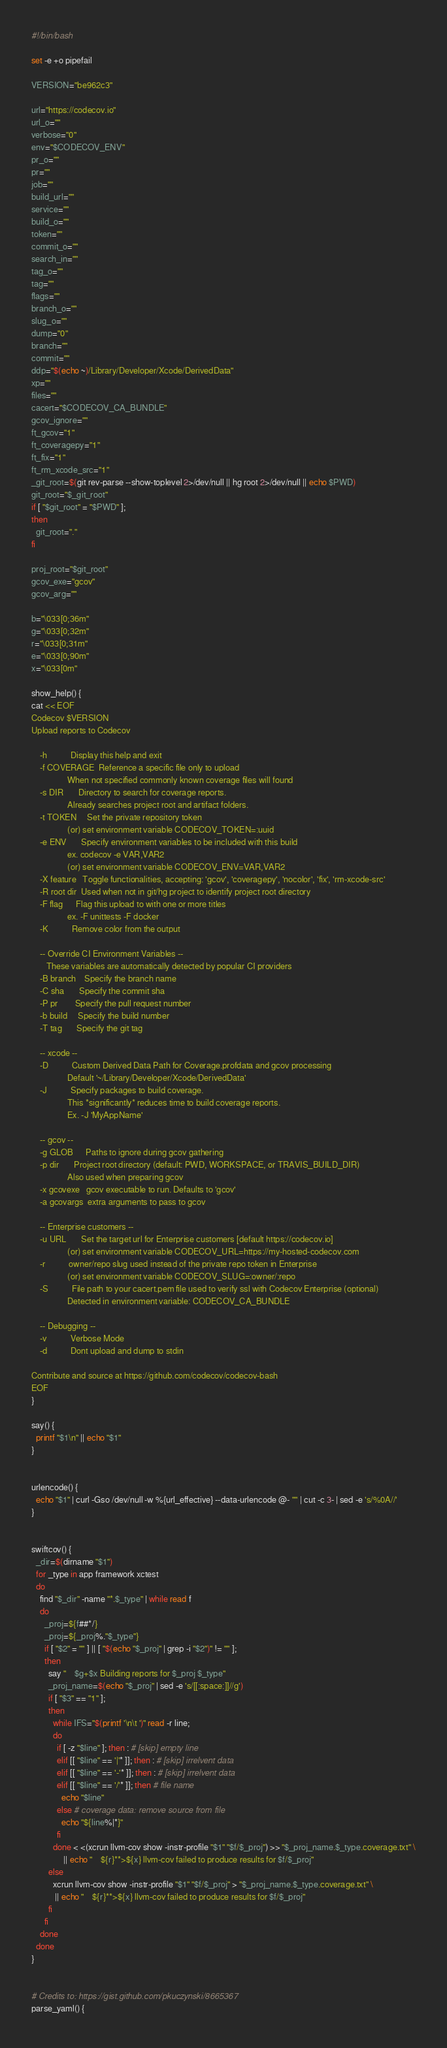<code> <loc_0><loc_0><loc_500><loc_500><_Bash_>
#!/bin/bash

set -e +o pipefail

VERSION="be962c3"

url="https://codecov.io"
url_o=""
verbose="0"
env="$CODECOV_ENV"
pr_o=""
pr=""
job=""
build_url=""
service=""
build_o=""
token=""
commit_o=""
search_in=""
tag_o=""
tag=""
flags=""
branch_o=""
slug_o=""
dump="0"
branch=""
commit=""
ddp="$(echo ~)/Library/Developer/Xcode/DerivedData"
xp=""
files=""
cacert="$CODECOV_CA_BUNDLE"
gcov_ignore=""
ft_gcov="1"
ft_coveragepy="1"
ft_fix="1"
ft_rm_xcode_src="1"
_git_root=$(git rev-parse --show-toplevel 2>/dev/null || hg root 2>/dev/null || echo $PWD)
git_root="$_git_root"
if [ "$git_root" = "$PWD" ];
then
  git_root="."
fi

proj_root="$git_root"
gcov_exe="gcov"
gcov_arg=""

b="\033[0;36m"
g="\033[0;32m"
r="\033[0;31m"
e="\033[0;90m"
x="\033[0m"

show_help() {
cat << EOF
Codecov $VERSION
Upload reports to Codecov

    -h           Display this help and exit
    -f COVERAGE  Reference a specific file only to upload
                 When not specified commonly known coverage files will found
    -s DIR       Directory to search for coverage reports.
                 Already searches project root and artifact folders.
    -t TOKEN     Set the private repository token
                 (or) set environment variable CODECOV_TOKEN=:uuid
    -e ENV       Specify environment variables to be included with this build
                 ex. codecov -e VAR,VAR2
                 (or) set environment variable CODECOV_ENV=VAR,VAR2
    -X feature   Toggle functionalities, accepting: 'gcov', 'coveragepy', 'nocolor', 'fix', 'rm-xcode-src'
    -R root dir  Used when not in git/hg project to identify project root directory
    -F flag      Flag this upload to with one or more titles
                 ex. -F unittests -F docker
    -K           Remove color from the output

    -- Override CI Environment Variables --
       These variables are automatically detected by popular CI providers
    -B branch    Specify the branch name
    -C sha       Specify the commit sha
    -P pr        Specify the pull request number
    -b build     Specify the build number
    -T tag       Specify the git tag

    -- xcode --
    -D           Custom Derived Data Path for Coverage.profdata and gcov processing
                 Default '~/Library/Developer/Xcode/DerivedData'
    -J           Specify packages to build coverage.
                 This *significantly* reduces time to build coverage reports.
                 Ex. -J 'MyAppName'

    -- gcov --
    -g GLOB      Paths to ignore during gcov gathering
    -p dir       Project root directory (default: PWD, WORKSPACE, or TRAVIS_BUILD_DIR)
                 Also used when preparing gcov
    -x gcovexe   gcov executable to run. Defaults to 'gcov'
    -a gcovargs  extra arguments to pass to gcov

    -- Enterprise customers --
    -u URL       Set the target url for Enterprise customers [default https://codecov.io]
                 (or) set environment variable CODECOV_URL=https://my-hosted-codecov.com
    -r           owner/repo slug used instead of the private repo token in Enterprise
                 (or) set environment variable CODECOV_SLUG=:owner/:repo
    -S           File path to your cacert.pem file used to verify ssl with Codecov Enterprise (optional)
                 Detected in environment variable: CODECOV_CA_BUNDLE

    -- Debugging --
    -v           Verbose Mode
    -d           Dont upload and dump to stdin

Contribute and source at https://github.com/codecov/codecov-bash
EOF
}

say() {
  printf "$1\n" || echo "$1"
}


urlencode() {
  echo "$1" | curl -Gso /dev/null -w %{url_effective} --data-urlencode @- "" | cut -c 3- | sed -e 's/%0A//'
}


swiftcov() {
  _dir=$(dirname "$1")
  for _type in app framework xctest
  do
    find "$_dir" -name "*.$_type" | while read f
    do
      _proj=${f##*/}
      _proj=${_proj%."$_type"}
      if [ "$2" = "" ] || [ "$(echo "$_proj" | grep -i "$2")" != "" ];
      then
        say "    $g+$x Building reports for $_proj $_type"
        _proj_name=$(echo "$_proj" | sed -e 's/[[:space:]]//g')
        if [ "$3" == "1" ];
        then
          while IFS="$(printf '\n\t ')" read -r line;
          do
            if [ -z "$line" ]; then : # [skip] empty line
            elif [[ "$line" == '|'* ]]; then : # [skip] irrelvent data
            elif [[ "$line" == '-'* ]]; then : # [skip] irrelvent data
            elif [[ "$line" == '/'* ]]; then # file name
              echo "$line"
            else # coverage data: remove source from file
              echo "${line%|*}"
            fi
          done < <(xcrun llvm-cov show -instr-profile "$1" "$f/$_proj") >> "$_proj_name.$_type.coverage.txt" \
               || echo "    ${r}**>${x} llvm-cov failed to produce results for $f/$_proj"
        else
          xcrun llvm-cov show -instr-profile "$1" "$f/$_proj" > "$_proj_name.$_type.coverage.txt" \
           || echo "    ${r}**>${x} llvm-cov failed to produce results for $f/$_proj"
        fi
      fi
    done
  done
}


# Credits to: https://gist.github.com/pkuczynski/8665367
parse_yaml() {</code> 